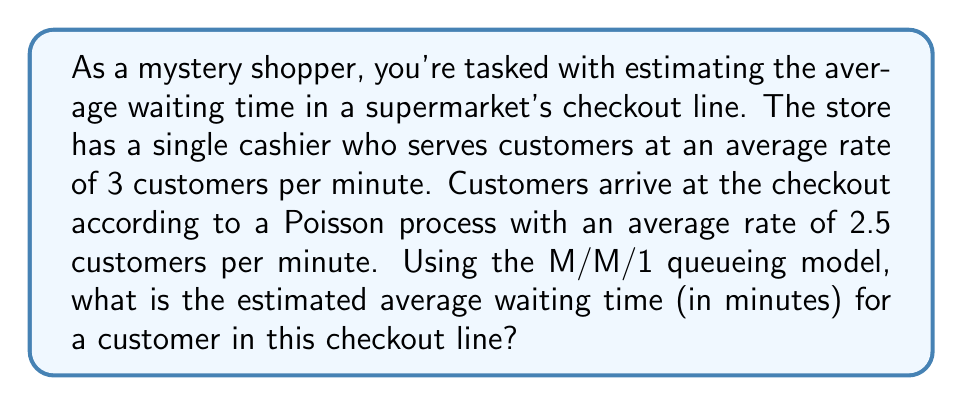Provide a solution to this math problem. Let's approach this step-by-step using the M/M/1 queueing model:

1. Identify the parameters:
   - Arrival rate: $\lambda = 2.5$ customers/minute
   - Service rate: $\mu = 3$ customers/minute

2. Calculate the utilization factor $\rho$:
   $$\rho = \frac{\lambda}{\mu} = \frac{2.5}{3} \approx 0.833$$

3. The average waiting time in an M/M/1 queue is given by the formula:
   $$W_q = \frac{\rho}{\mu - \lambda}$$

4. Substitute the values:
   $$W_q = \frac{0.833}{3 - 2.5} = \frac{0.833}{0.5} = 1.666$$

5. The result is in minutes, so we don't need to convert units.

Therefore, the estimated average waiting time for a customer in this checkout line is approximately 1.666 minutes.
Answer: 1.666 minutes 